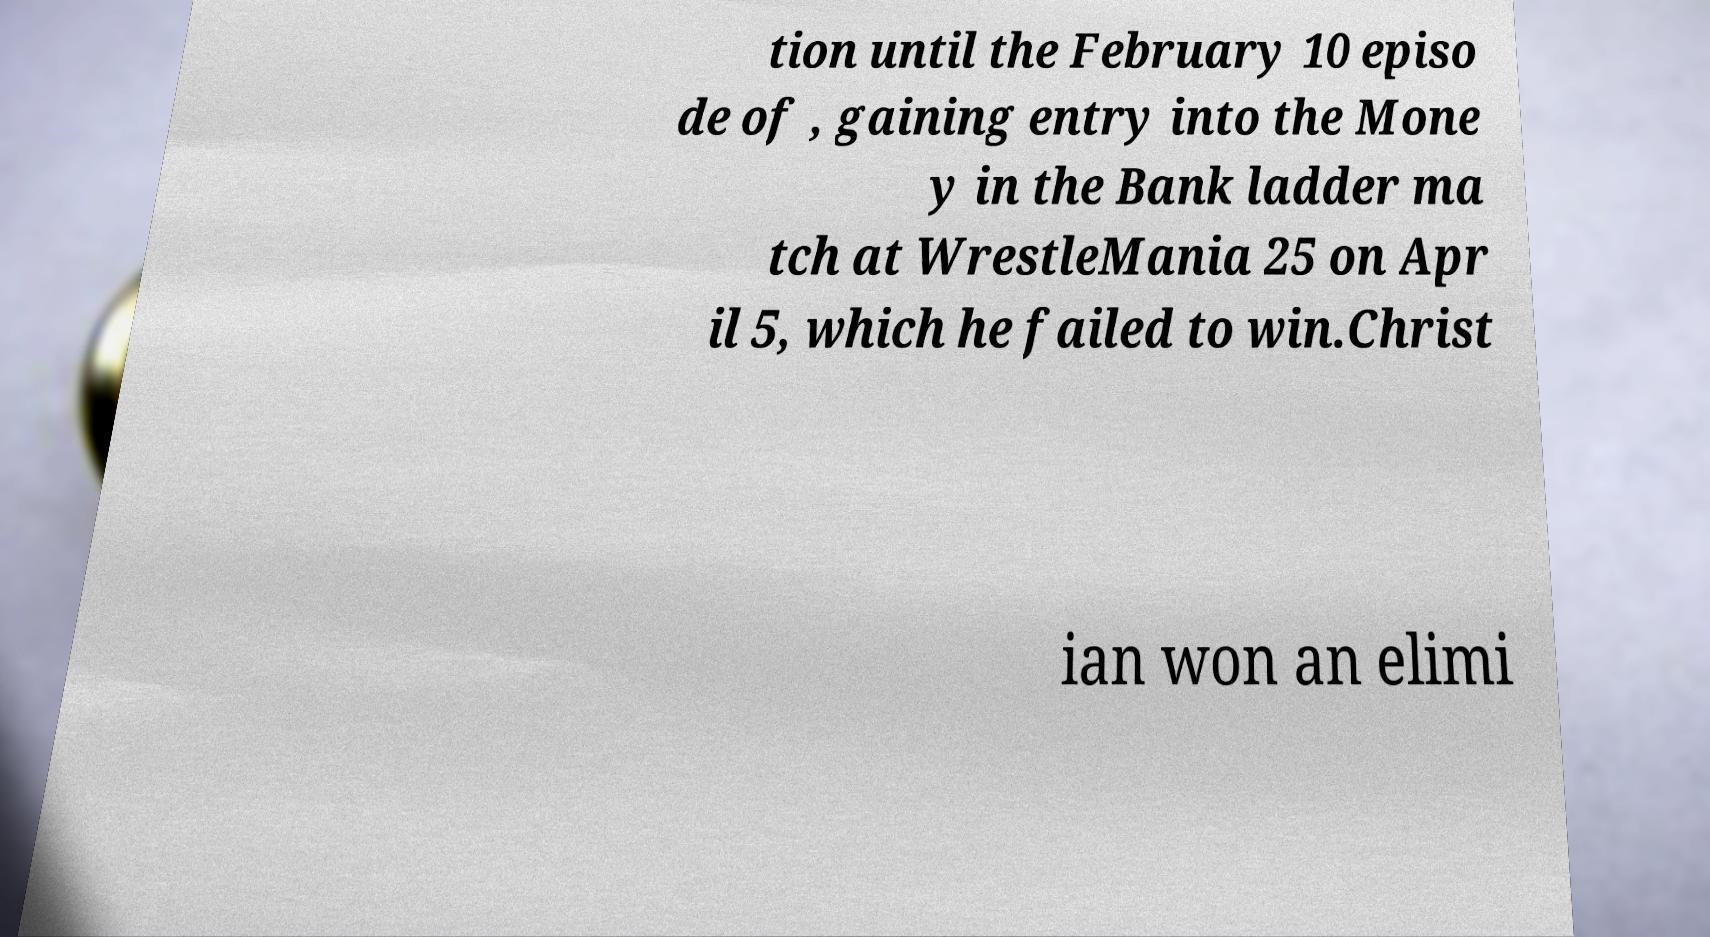I need the written content from this picture converted into text. Can you do that? tion until the February 10 episo de of , gaining entry into the Mone y in the Bank ladder ma tch at WrestleMania 25 on Apr il 5, which he failed to win.Christ ian won an elimi 